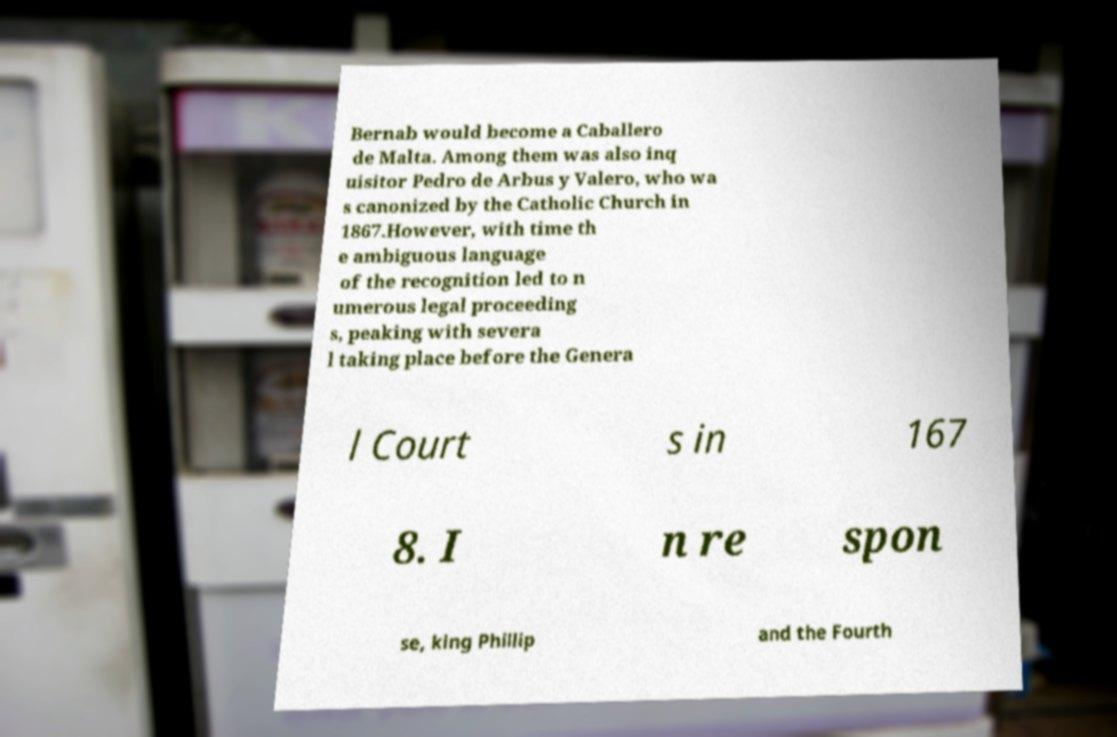Could you assist in decoding the text presented in this image and type it out clearly? Bernab would become a Caballero de Malta. Among them was also inq uisitor Pedro de Arbus y Valero, who wa s canonized by the Catholic Church in 1867.However, with time th e ambiguous language of the recognition led to n umerous legal proceeding s, peaking with severa l taking place before the Genera l Court s in 167 8. I n re spon se, king Phillip and the Fourth 